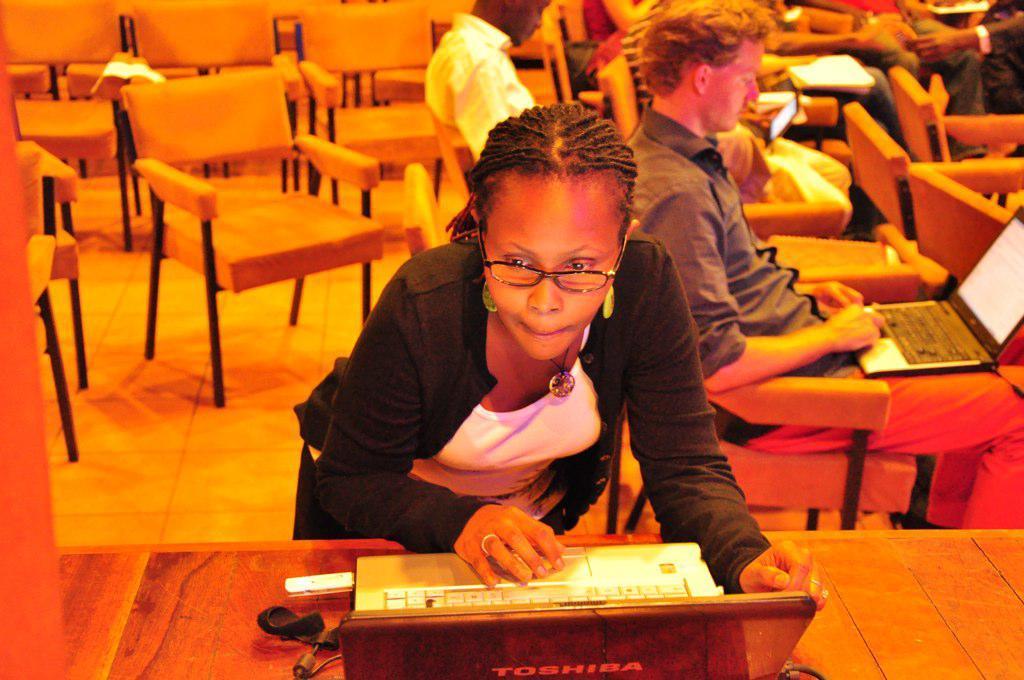Could you give a brief overview of what you see in this image? In the given image we can see there are many people and the people are working on the laptop. This is a laptop on which it is written Toshiba. There are many chairs. 